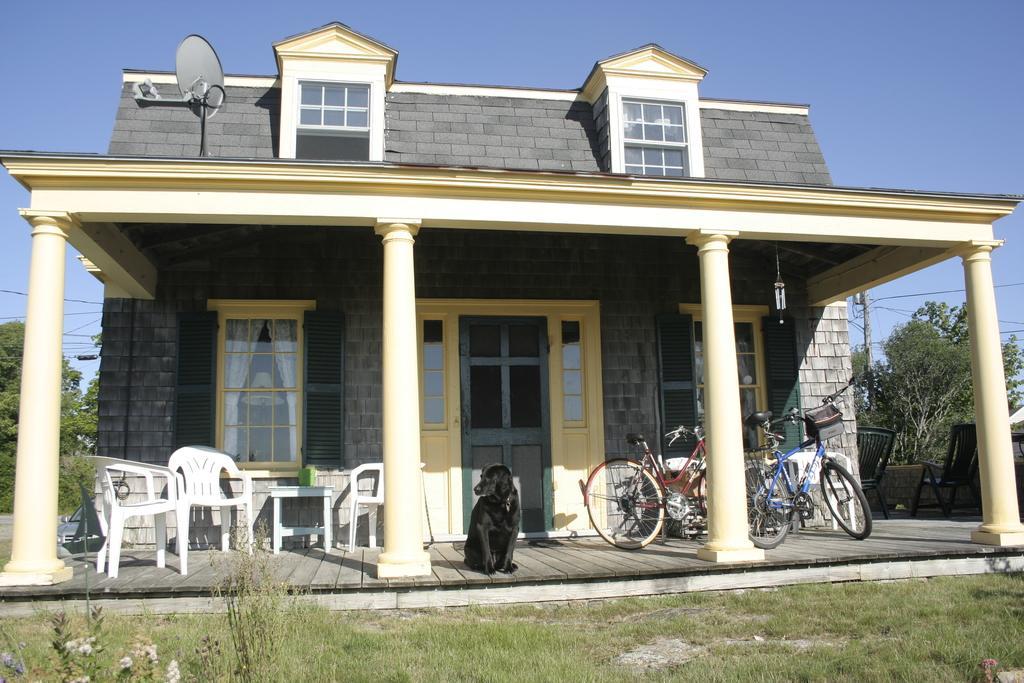How would you summarize this image in a sentence or two? In the image we can see there is a dog sitting on the veranda and there are bicycles kept on the veranda. There is a signal dish kept on the top of the building, there are chairs and table kept on the veranda. There is a house made up of bricks and there is ground covered with grass. Behind there are trees and there is a clear sky. 